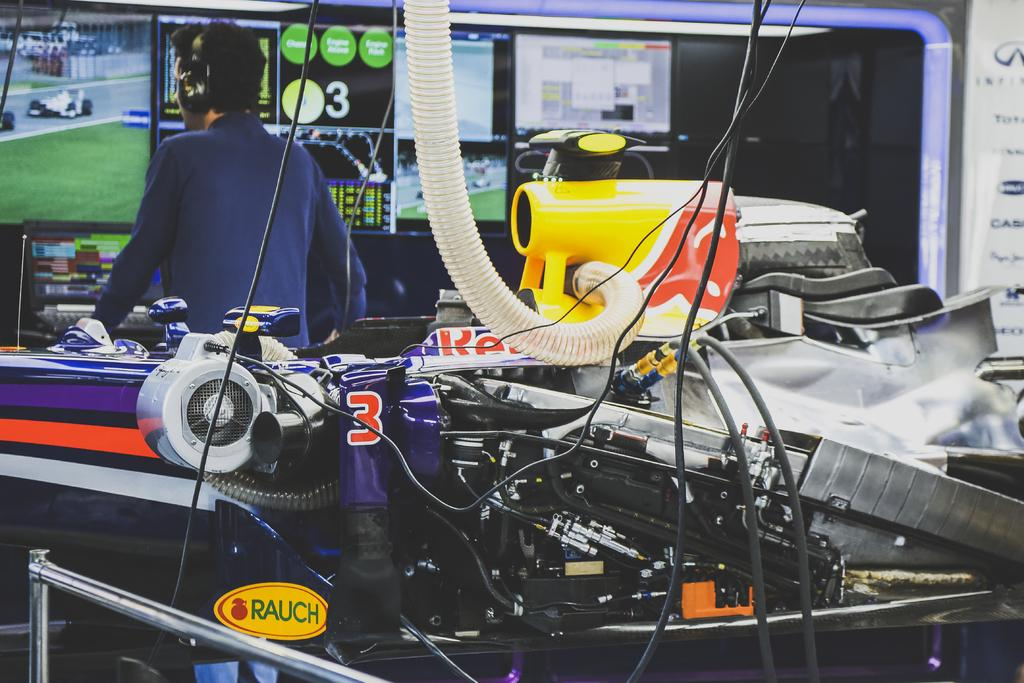What is the main subject of the image? There is a vehicle in the image. What can be seen in the background of the image? There are digital screens and a man in the background of the image. What is the man wearing in the image? The man is wearing headphones in the image. Can you see a dock in the image? There is no dock present in the image. Is the vehicle smashing into the digital screens in the image? No, the vehicle is not smashing into the digital screens in the image. 